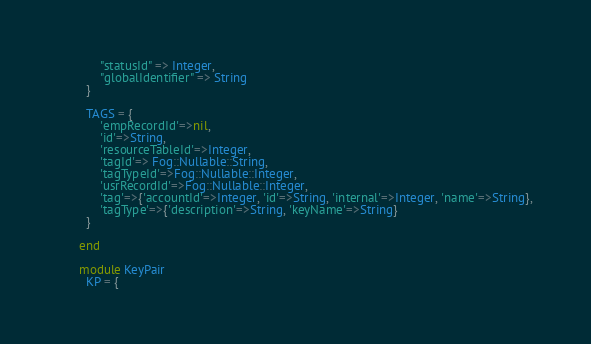Convert code to text. <code><loc_0><loc_0><loc_500><loc_500><_Ruby_>            "statusId" => Integer,
            "globalIdentifier" => String
        }

        TAGS = {
            'empRecordId'=>nil,
            'id'=>String,
            'resourceTableId'=>Integer,
            'tagId'=> Fog::Nullable::String,
            'tagTypeId'=>Fog::Nullable::Integer,
            'usrRecordId'=>Fog::Nullable::Integer,
            'tag'=>{'accountId'=>Integer, 'id'=>String, 'internal'=>Integer, 'name'=>String},
            'tagType'=>{'description'=>String, 'keyName'=>String}
        }

      end

      module KeyPair
        KP = {</code> 